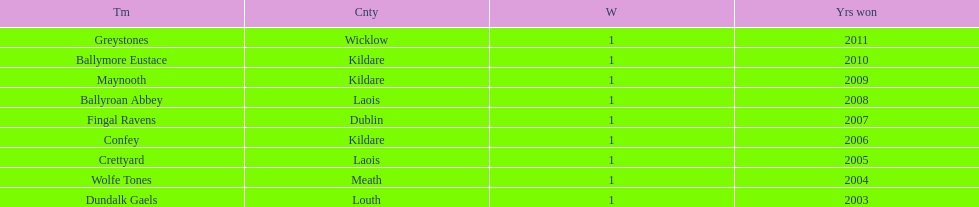What is the number of wins for confey 1. 